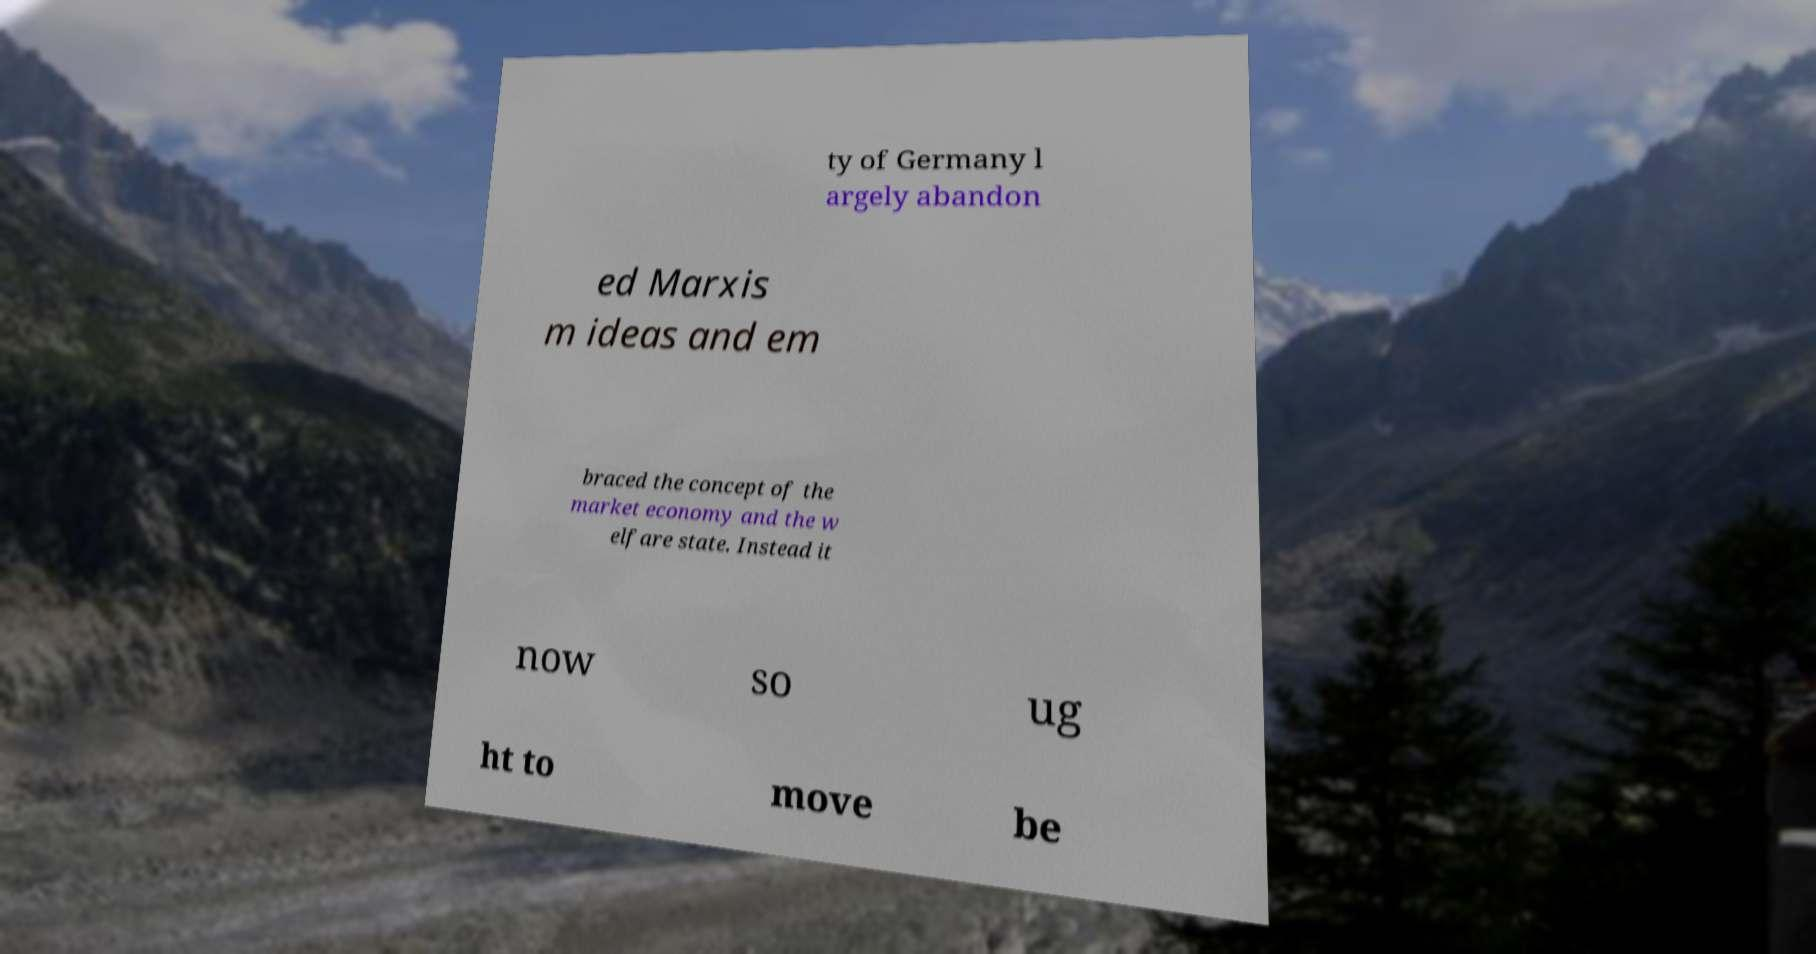There's text embedded in this image that I need extracted. Can you transcribe it verbatim? ty of Germany l argely abandon ed Marxis m ideas and em braced the concept of the market economy and the w elfare state. Instead it now so ug ht to move be 